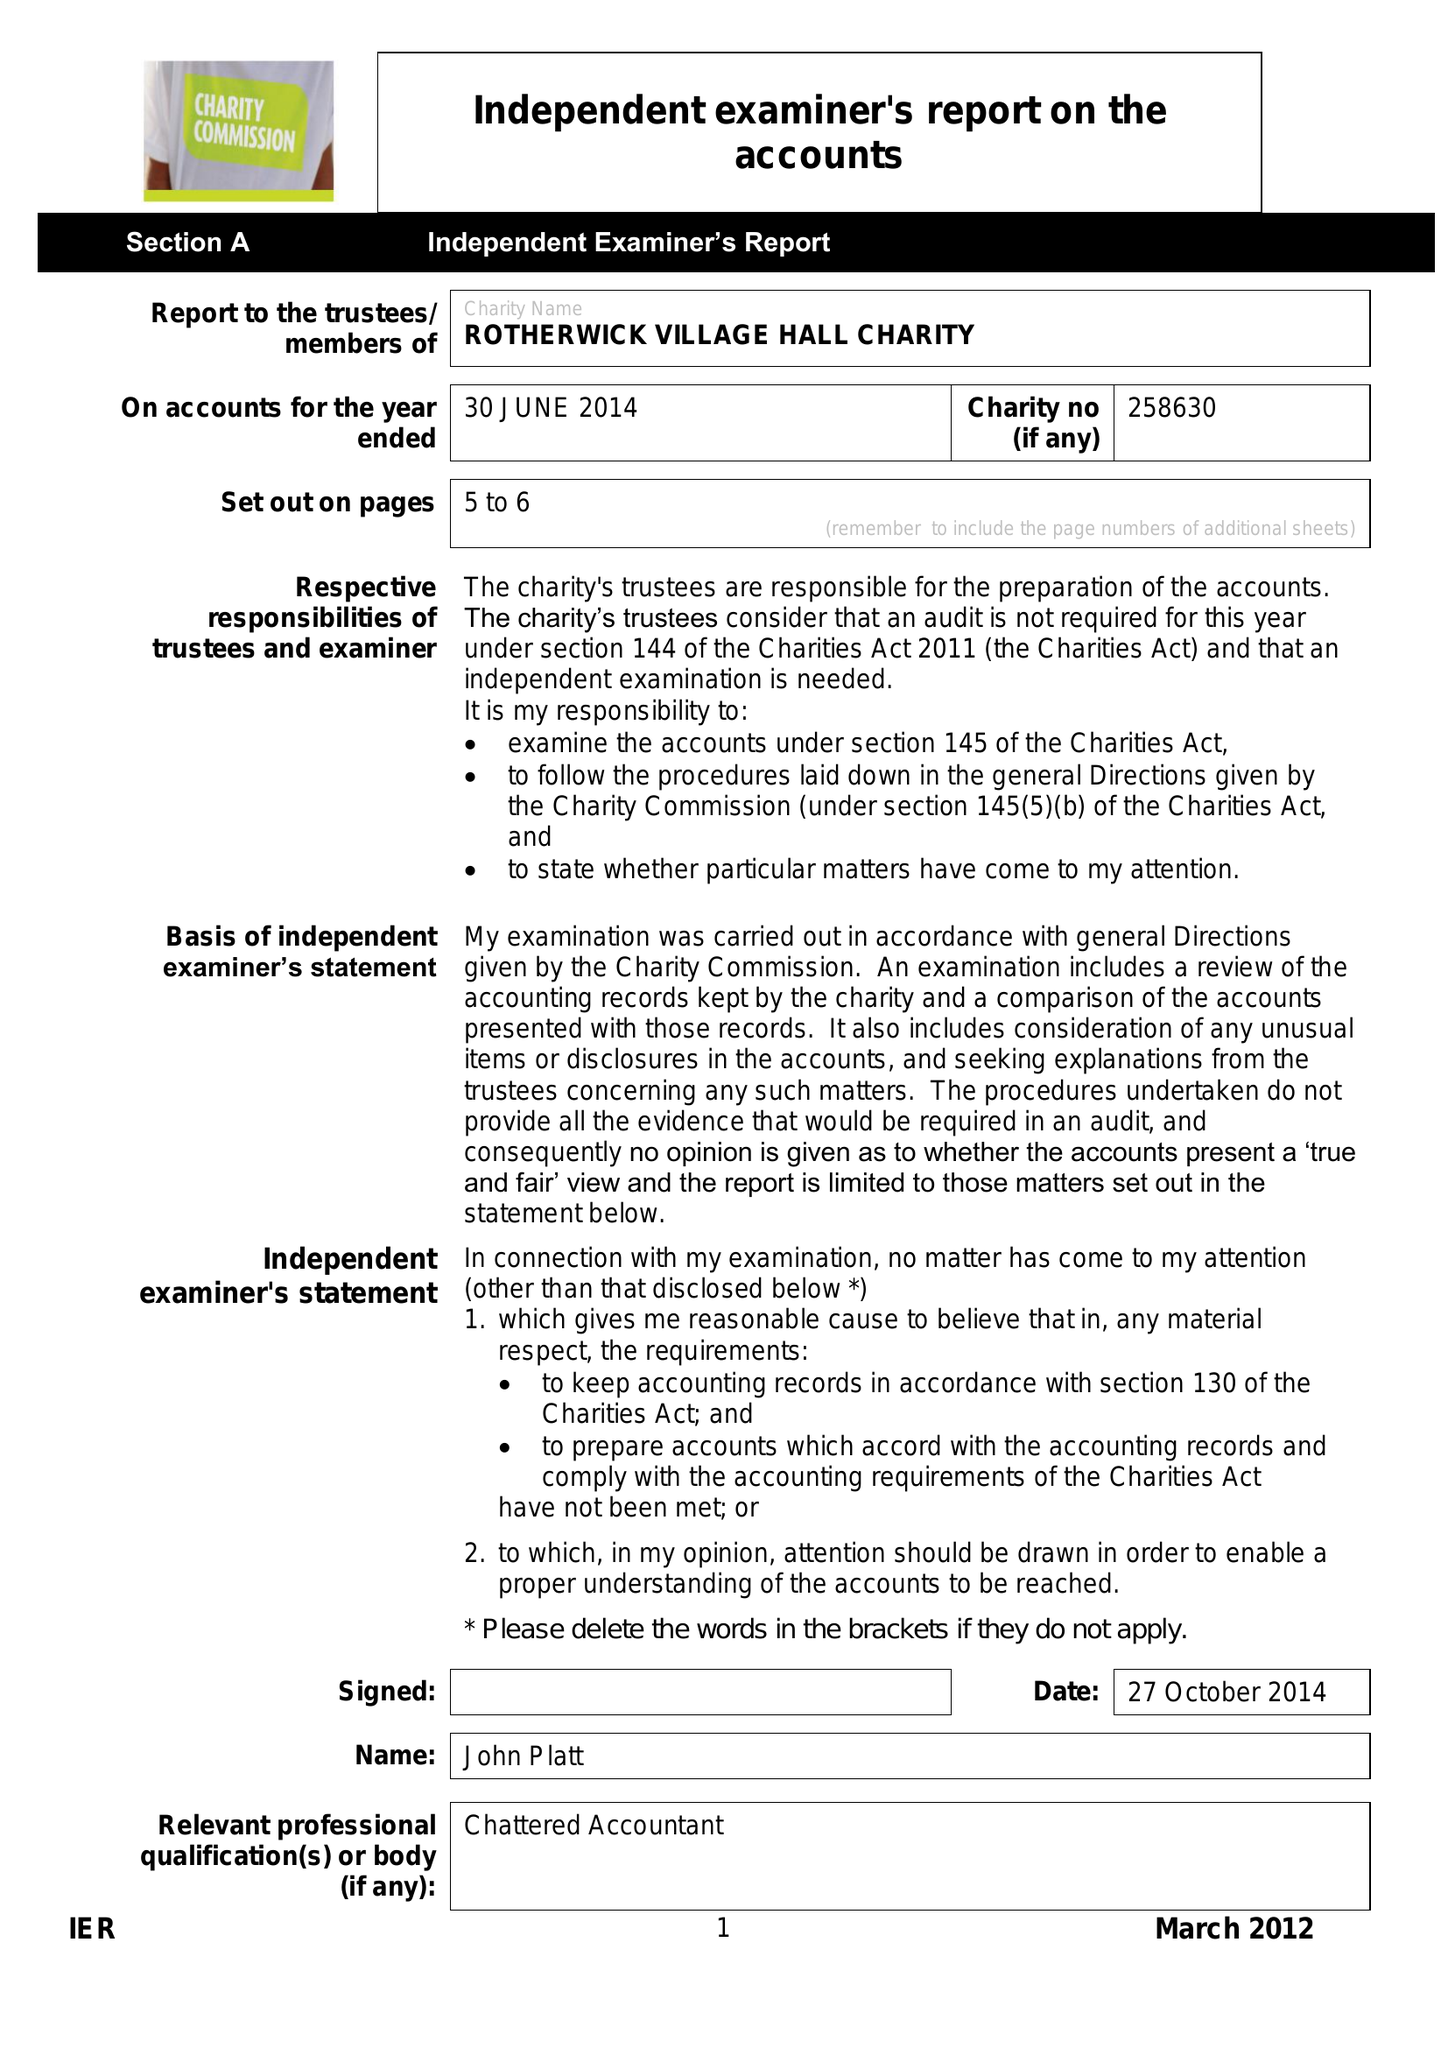What is the value for the address__post_town?
Answer the question using a single word or phrase. HOOK 